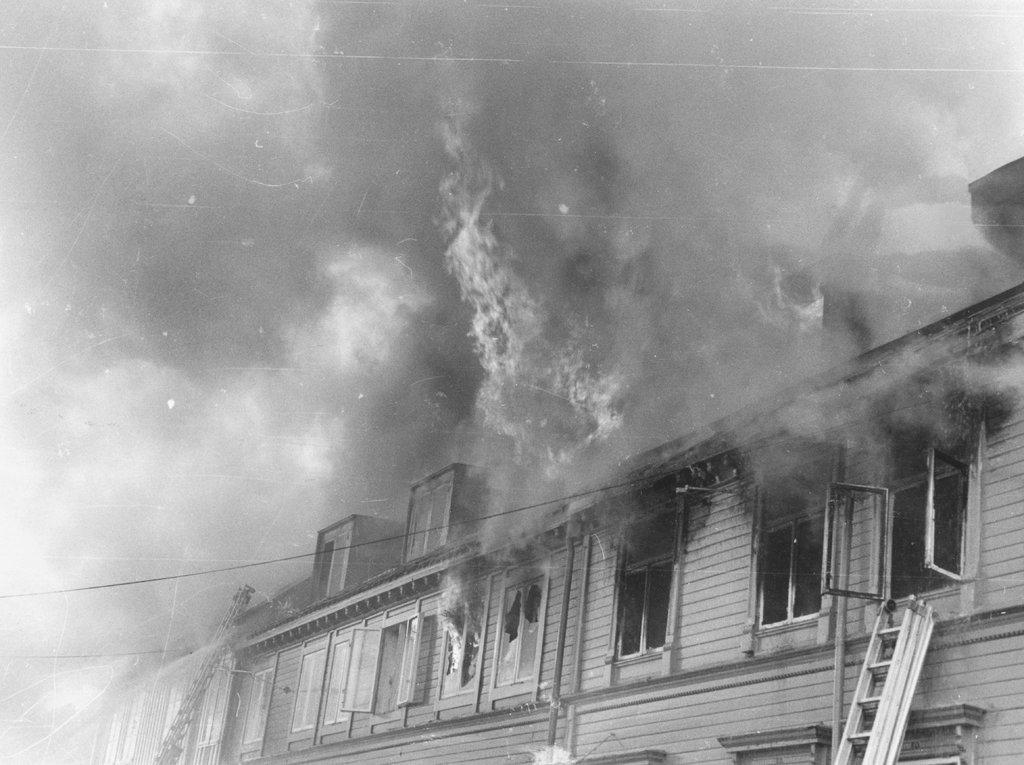What structure is present in the image? There is a building in the image. What is happening to the building? The building has fire. What tools are present near the building? There are ladders in front of the building. What can be seen in the background of the image? The sky and smoke are visible in the background of the image. Can you see a plough being used in the image? There is no plough present in the image. What part of the brain is visible in the image? There is no brain present in the image. 